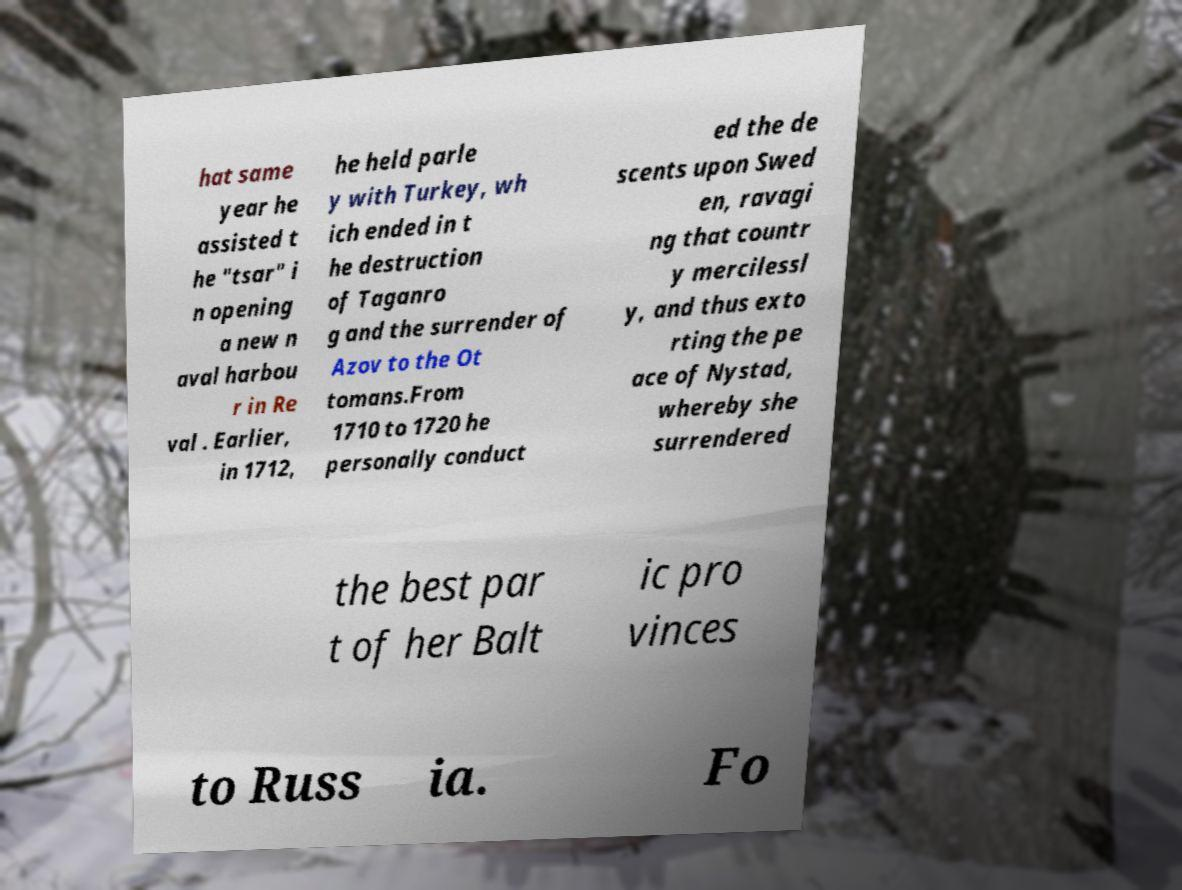Could you extract and type out the text from this image? hat same year he assisted t he "tsar" i n opening a new n aval harbou r in Re val . Earlier, in 1712, he held parle y with Turkey, wh ich ended in t he destruction of Taganro g and the surrender of Azov to the Ot tomans.From 1710 to 1720 he personally conduct ed the de scents upon Swed en, ravagi ng that countr y mercilessl y, and thus exto rting the pe ace of Nystad, whereby she surrendered the best par t of her Balt ic pro vinces to Russ ia. Fo 